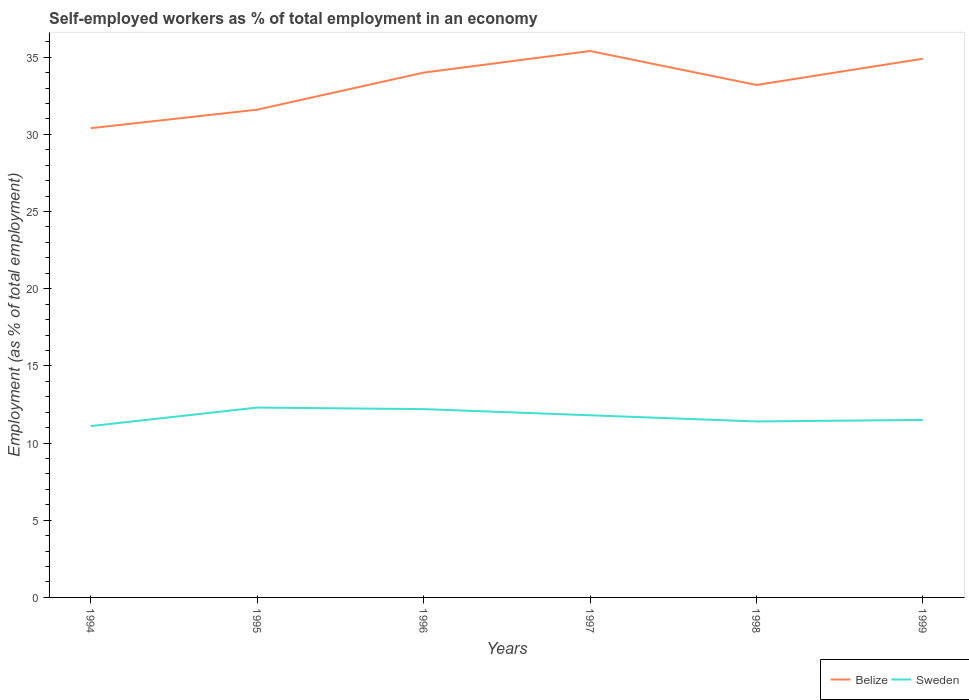How many different coloured lines are there?
Make the answer very short. 2. Across all years, what is the maximum percentage of self-employed workers in Sweden?
Your answer should be very brief. 11.1. In which year was the percentage of self-employed workers in Belize maximum?
Give a very brief answer. 1994. What is the total percentage of self-employed workers in Sweden in the graph?
Make the answer very short. 0.3. What is the difference between the highest and the second highest percentage of self-employed workers in Belize?
Your response must be concise. 5. Is the percentage of self-employed workers in Sweden strictly greater than the percentage of self-employed workers in Belize over the years?
Offer a very short reply. Yes. How many years are there in the graph?
Make the answer very short. 6. What is the difference between two consecutive major ticks on the Y-axis?
Make the answer very short. 5. Are the values on the major ticks of Y-axis written in scientific E-notation?
Provide a succinct answer. No. Does the graph contain any zero values?
Your response must be concise. No. What is the title of the graph?
Your answer should be very brief. Self-employed workers as % of total employment in an economy. Does "Mozambique" appear as one of the legend labels in the graph?
Your response must be concise. No. What is the label or title of the Y-axis?
Make the answer very short. Employment (as % of total employment). What is the Employment (as % of total employment) of Belize in 1994?
Your answer should be compact. 30.4. What is the Employment (as % of total employment) of Sweden in 1994?
Your answer should be compact. 11.1. What is the Employment (as % of total employment) of Belize in 1995?
Your response must be concise. 31.6. What is the Employment (as % of total employment) of Sweden in 1995?
Provide a succinct answer. 12.3. What is the Employment (as % of total employment) in Belize in 1996?
Make the answer very short. 34. What is the Employment (as % of total employment) in Sweden in 1996?
Offer a terse response. 12.2. What is the Employment (as % of total employment) in Belize in 1997?
Give a very brief answer. 35.4. What is the Employment (as % of total employment) of Sweden in 1997?
Make the answer very short. 11.8. What is the Employment (as % of total employment) in Belize in 1998?
Offer a terse response. 33.2. What is the Employment (as % of total employment) in Sweden in 1998?
Provide a succinct answer. 11.4. What is the Employment (as % of total employment) of Belize in 1999?
Your answer should be very brief. 34.9. Across all years, what is the maximum Employment (as % of total employment) in Belize?
Your answer should be very brief. 35.4. Across all years, what is the maximum Employment (as % of total employment) in Sweden?
Make the answer very short. 12.3. Across all years, what is the minimum Employment (as % of total employment) in Belize?
Offer a terse response. 30.4. Across all years, what is the minimum Employment (as % of total employment) in Sweden?
Your answer should be compact. 11.1. What is the total Employment (as % of total employment) in Belize in the graph?
Your response must be concise. 199.5. What is the total Employment (as % of total employment) of Sweden in the graph?
Offer a terse response. 70.3. What is the difference between the Employment (as % of total employment) in Sweden in 1994 and that in 1996?
Your answer should be very brief. -1.1. What is the difference between the Employment (as % of total employment) in Sweden in 1994 and that in 1997?
Your answer should be compact. -0.7. What is the difference between the Employment (as % of total employment) of Sweden in 1994 and that in 1998?
Give a very brief answer. -0.3. What is the difference between the Employment (as % of total employment) in Sweden in 1995 and that in 1996?
Make the answer very short. 0.1. What is the difference between the Employment (as % of total employment) in Belize in 1995 and that in 1997?
Make the answer very short. -3.8. What is the difference between the Employment (as % of total employment) of Sweden in 1995 and that in 1997?
Make the answer very short. 0.5. What is the difference between the Employment (as % of total employment) in Belize in 1995 and that in 1998?
Offer a terse response. -1.6. What is the difference between the Employment (as % of total employment) of Sweden in 1995 and that in 1998?
Your answer should be compact. 0.9. What is the difference between the Employment (as % of total employment) of Belize in 1995 and that in 1999?
Keep it short and to the point. -3.3. What is the difference between the Employment (as % of total employment) in Belize in 1996 and that in 1997?
Your response must be concise. -1.4. What is the difference between the Employment (as % of total employment) in Sweden in 1996 and that in 1997?
Make the answer very short. 0.4. What is the difference between the Employment (as % of total employment) of Belize in 1997 and that in 1998?
Offer a terse response. 2.2. What is the difference between the Employment (as % of total employment) of Sweden in 1997 and that in 1998?
Provide a succinct answer. 0.4. What is the difference between the Employment (as % of total employment) in Belize in 1997 and that in 1999?
Provide a short and direct response. 0.5. What is the difference between the Employment (as % of total employment) in Belize in 1994 and the Employment (as % of total employment) in Sweden in 1995?
Give a very brief answer. 18.1. What is the difference between the Employment (as % of total employment) in Belize in 1994 and the Employment (as % of total employment) in Sweden in 1997?
Make the answer very short. 18.6. What is the difference between the Employment (as % of total employment) in Belize in 1994 and the Employment (as % of total employment) in Sweden in 1999?
Give a very brief answer. 18.9. What is the difference between the Employment (as % of total employment) of Belize in 1995 and the Employment (as % of total employment) of Sweden in 1997?
Provide a short and direct response. 19.8. What is the difference between the Employment (as % of total employment) of Belize in 1995 and the Employment (as % of total employment) of Sweden in 1998?
Ensure brevity in your answer.  20.2. What is the difference between the Employment (as % of total employment) of Belize in 1995 and the Employment (as % of total employment) of Sweden in 1999?
Provide a short and direct response. 20.1. What is the difference between the Employment (as % of total employment) in Belize in 1996 and the Employment (as % of total employment) in Sweden in 1997?
Your answer should be very brief. 22.2. What is the difference between the Employment (as % of total employment) in Belize in 1996 and the Employment (as % of total employment) in Sweden in 1998?
Offer a terse response. 22.6. What is the difference between the Employment (as % of total employment) in Belize in 1997 and the Employment (as % of total employment) in Sweden in 1998?
Provide a short and direct response. 24. What is the difference between the Employment (as % of total employment) of Belize in 1997 and the Employment (as % of total employment) of Sweden in 1999?
Offer a very short reply. 23.9. What is the difference between the Employment (as % of total employment) of Belize in 1998 and the Employment (as % of total employment) of Sweden in 1999?
Give a very brief answer. 21.7. What is the average Employment (as % of total employment) of Belize per year?
Give a very brief answer. 33.25. What is the average Employment (as % of total employment) in Sweden per year?
Make the answer very short. 11.72. In the year 1994, what is the difference between the Employment (as % of total employment) in Belize and Employment (as % of total employment) in Sweden?
Provide a short and direct response. 19.3. In the year 1995, what is the difference between the Employment (as % of total employment) of Belize and Employment (as % of total employment) of Sweden?
Make the answer very short. 19.3. In the year 1996, what is the difference between the Employment (as % of total employment) of Belize and Employment (as % of total employment) of Sweden?
Your response must be concise. 21.8. In the year 1997, what is the difference between the Employment (as % of total employment) of Belize and Employment (as % of total employment) of Sweden?
Provide a succinct answer. 23.6. In the year 1998, what is the difference between the Employment (as % of total employment) in Belize and Employment (as % of total employment) in Sweden?
Your response must be concise. 21.8. In the year 1999, what is the difference between the Employment (as % of total employment) in Belize and Employment (as % of total employment) in Sweden?
Your answer should be compact. 23.4. What is the ratio of the Employment (as % of total employment) in Belize in 1994 to that in 1995?
Your answer should be very brief. 0.96. What is the ratio of the Employment (as % of total employment) of Sweden in 1994 to that in 1995?
Give a very brief answer. 0.9. What is the ratio of the Employment (as % of total employment) of Belize in 1994 to that in 1996?
Keep it short and to the point. 0.89. What is the ratio of the Employment (as % of total employment) of Sweden in 1994 to that in 1996?
Offer a terse response. 0.91. What is the ratio of the Employment (as % of total employment) of Belize in 1994 to that in 1997?
Keep it short and to the point. 0.86. What is the ratio of the Employment (as % of total employment) of Sweden in 1994 to that in 1997?
Your answer should be compact. 0.94. What is the ratio of the Employment (as % of total employment) of Belize in 1994 to that in 1998?
Offer a very short reply. 0.92. What is the ratio of the Employment (as % of total employment) of Sweden in 1994 to that in 1998?
Keep it short and to the point. 0.97. What is the ratio of the Employment (as % of total employment) in Belize in 1994 to that in 1999?
Make the answer very short. 0.87. What is the ratio of the Employment (as % of total employment) in Sweden in 1994 to that in 1999?
Give a very brief answer. 0.97. What is the ratio of the Employment (as % of total employment) of Belize in 1995 to that in 1996?
Ensure brevity in your answer.  0.93. What is the ratio of the Employment (as % of total employment) in Sweden in 1995 to that in 1996?
Keep it short and to the point. 1.01. What is the ratio of the Employment (as % of total employment) in Belize in 1995 to that in 1997?
Ensure brevity in your answer.  0.89. What is the ratio of the Employment (as % of total employment) in Sweden in 1995 to that in 1997?
Give a very brief answer. 1.04. What is the ratio of the Employment (as % of total employment) of Belize in 1995 to that in 1998?
Your answer should be compact. 0.95. What is the ratio of the Employment (as % of total employment) in Sweden in 1995 to that in 1998?
Offer a terse response. 1.08. What is the ratio of the Employment (as % of total employment) in Belize in 1995 to that in 1999?
Your response must be concise. 0.91. What is the ratio of the Employment (as % of total employment) of Sweden in 1995 to that in 1999?
Your answer should be compact. 1.07. What is the ratio of the Employment (as % of total employment) of Belize in 1996 to that in 1997?
Provide a short and direct response. 0.96. What is the ratio of the Employment (as % of total employment) in Sweden in 1996 to that in 1997?
Your answer should be compact. 1.03. What is the ratio of the Employment (as % of total employment) in Belize in 1996 to that in 1998?
Offer a very short reply. 1.02. What is the ratio of the Employment (as % of total employment) in Sweden in 1996 to that in 1998?
Provide a succinct answer. 1.07. What is the ratio of the Employment (as % of total employment) in Belize in 1996 to that in 1999?
Give a very brief answer. 0.97. What is the ratio of the Employment (as % of total employment) of Sweden in 1996 to that in 1999?
Ensure brevity in your answer.  1.06. What is the ratio of the Employment (as % of total employment) in Belize in 1997 to that in 1998?
Make the answer very short. 1.07. What is the ratio of the Employment (as % of total employment) of Sweden in 1997 to that in 1998?
Ensure brevity in your answer.  1.04. What is the ratio of the Employment (as % of total employment) in Belize in 1997 to that in 1999?
Give a very brief answer. 1.01. What is the ratio of the Employment (as % of total employment) of Sweden in 1997 to that in 1999?
Keep it short and to the point. 1.03. What is the ratio of the Employment (as % of total employment) of Belize in 1998 to that in 1999?
Ensure brevity in your answer.  0.95. What is the ratio of the Employment (as % of total employment) of Sweden in 1998 to that in 1999?
Give a very brief answer. 0.99. What is the difference between the highest and the second highest Employment (as % of total employment) in Belize?
Provide a short and direct response. 0.5. What is the difference between the highest and the second highest Employment (as % of total employment) in Sweden?
Your response must be concise. 0.1. 